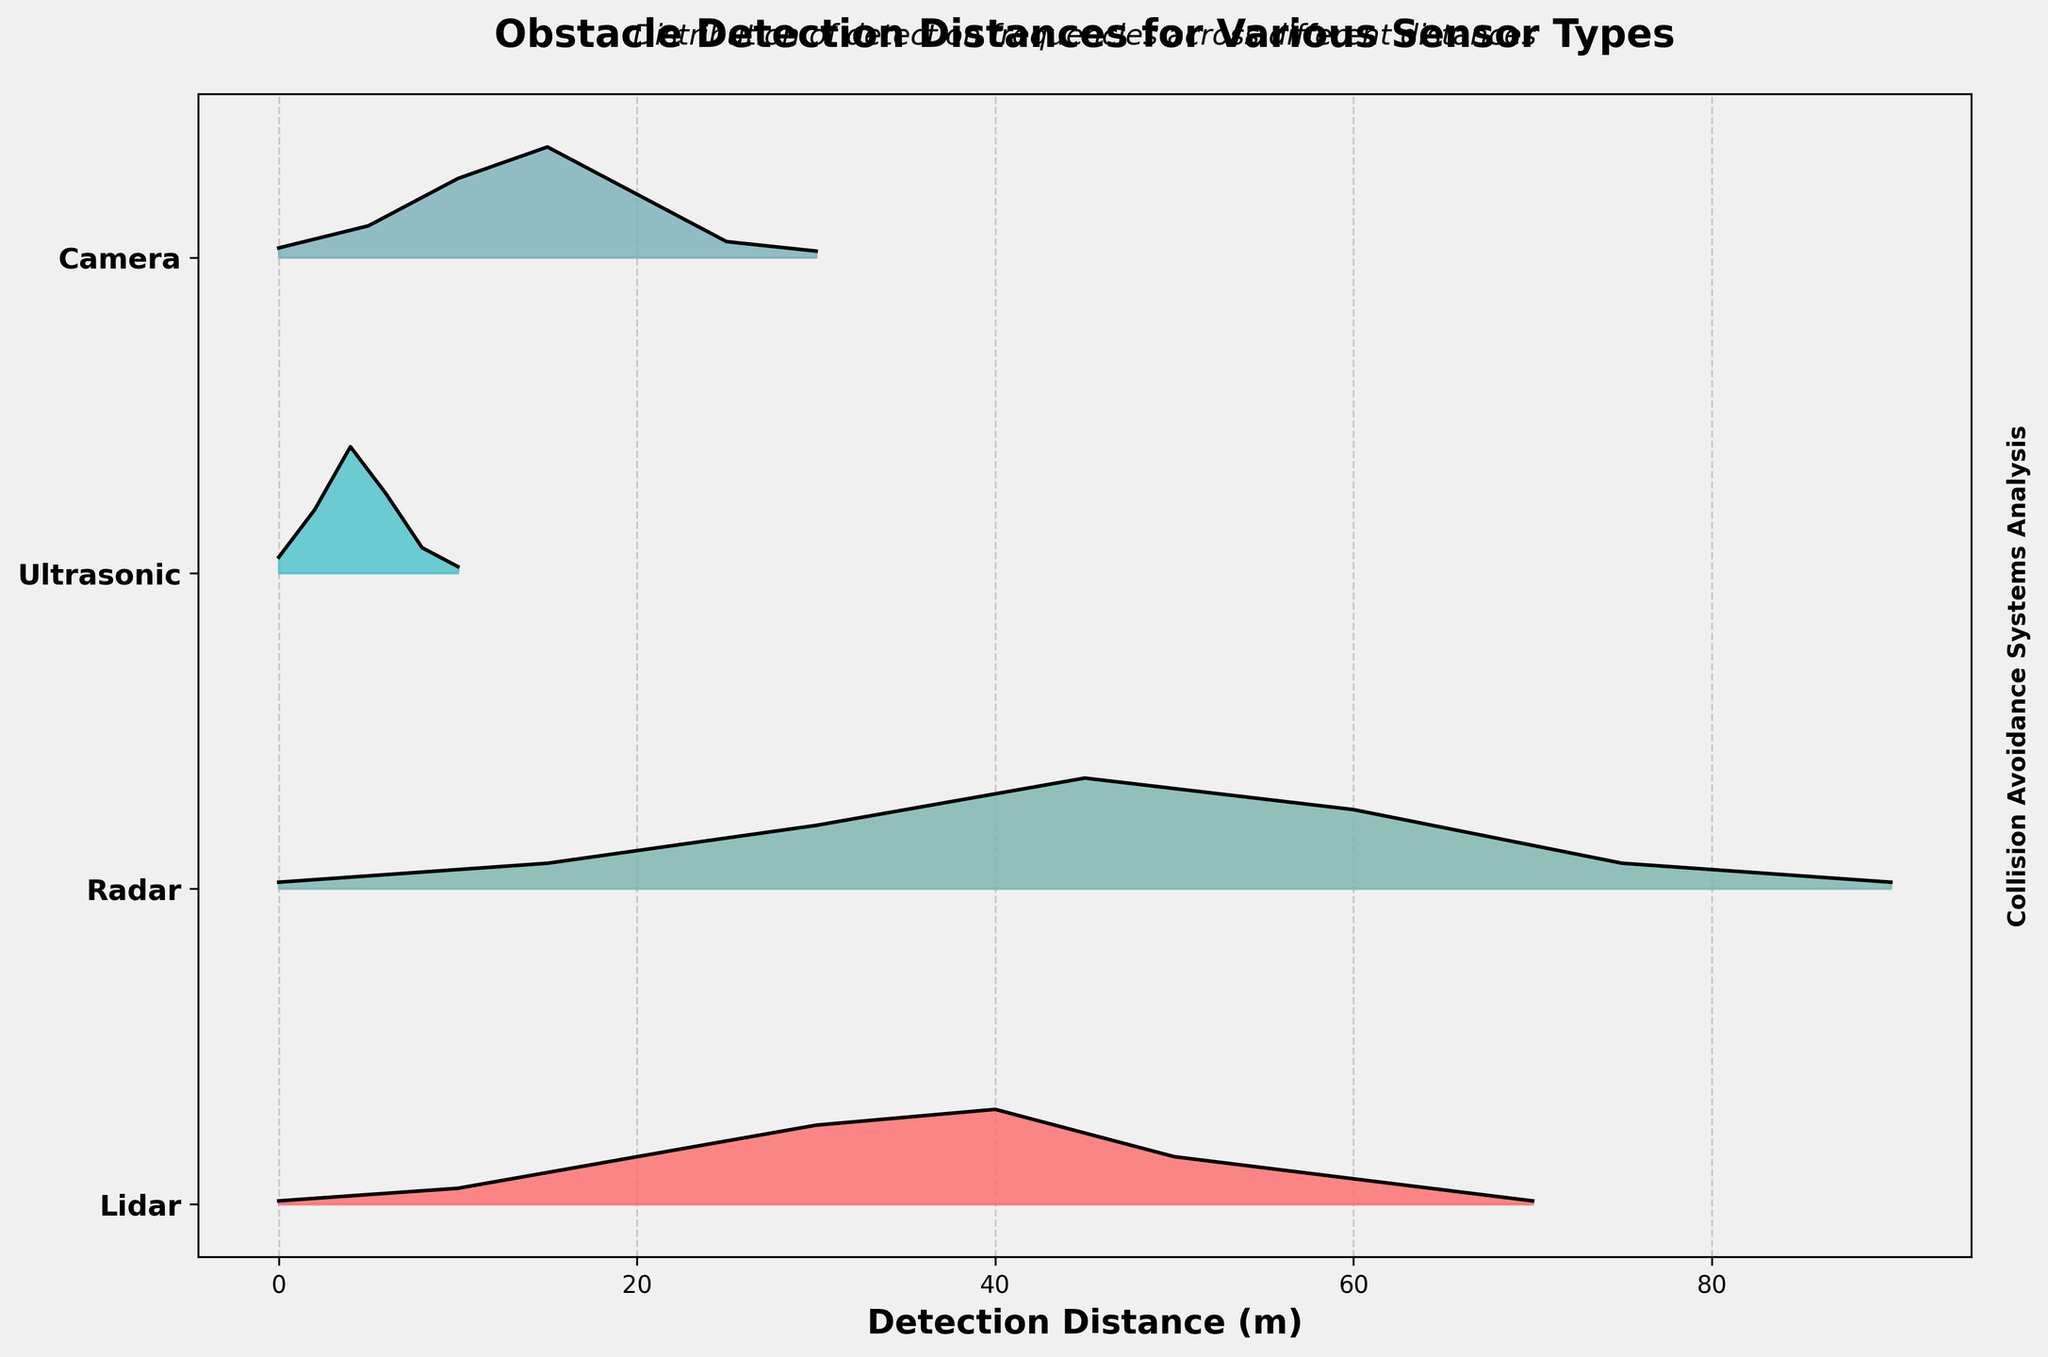What is the title of the figure? The title is typically located at the top of the plot and serves as a summary of what the plot represents. In this case, it reads, "Obstacle Detection Distances for Various Sensor Types."
Answer: Obstacle Detection Distances for Various Sensor Types What are the four sensor types represented in the plot? The y-axis of the ridgeline plot labels the different sensor types. These are listed sequentially: Lidar, Radar, Ultrasonic, and Camera.
Answer: Lidar, Radar, Ultrasonic, Camera Which sensor type has the highest peak frequency for obstacle detection at respective distances? By looking at each ridgeline, the peak frequency for each sensor is identified by the height of the ridgeline (y-axis). The highest peaks correspond to Lidar at 40m, Radar at 45m, Ultrasonic at 4m, and Camera at 15m. Out of these, the Ultrasonic sensor type has the highest peak frequency.
Answer: Ultrasonic At what distance is the peak frequency observed for the Lidar sensor? The distance axis (x-axis) and the height of the ridgeline indicate the peak frequency occurrence. For Lidar, the highest ridgeline is noticed at 40 meters.
Answer: 40 meters How does the peak detection distance for the Camera sensor compare to the Lidar sensor? The peak detection distance for Camera can be identified at the highest point of its ridgeline, which is 15 meters. For Lidar, it is 40 meters. By comparing these distances, Camera's peak detection distance is shorter than Lidar's.
Answer: Camera's peak detection distance is shorter than Lidar's Which sensor's detection frequencies spread more evenly over a range of distances? The spread of detection frequencies can be observed by how flat and wide the ridgeline is. Radar's ridgeline appears more spread out across multiple distances (15m to 90m) compared to others, implying a more even distribution.
Answer: Radar What is the subtitle of the plot? The subtitle is found just beneath the title and provides additional context to the plot, which is "Distribution of detection frequencies across different distances."
Answer: Distribution of detection frequencies across different distances 